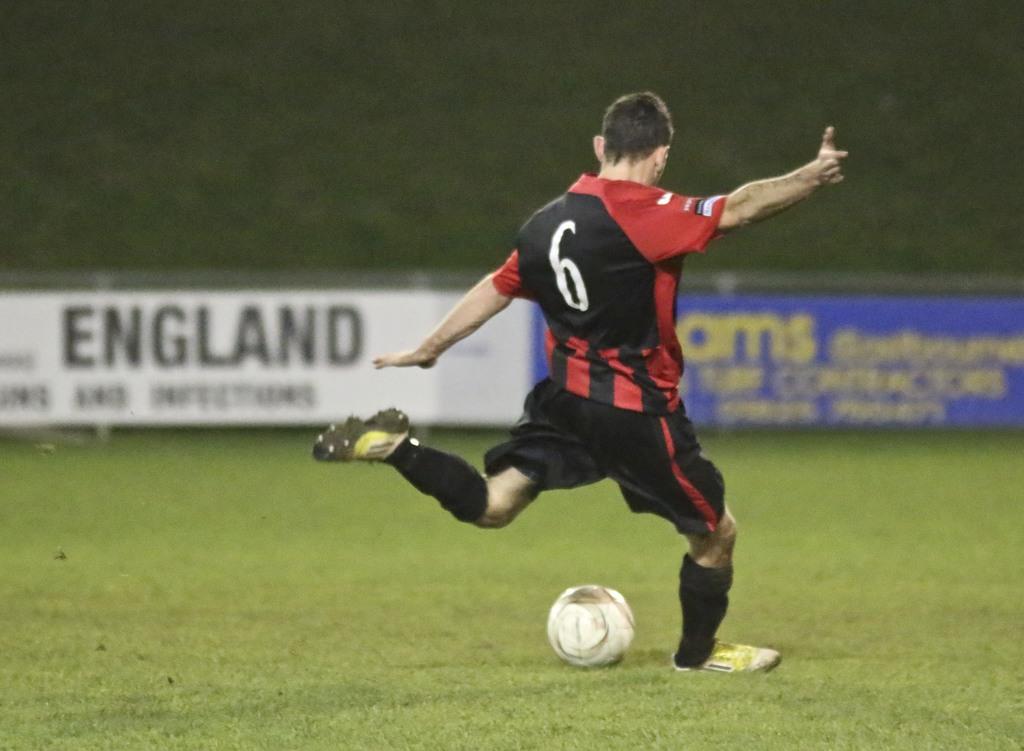What's the number on the back of the player's jersey?
Offer a very short reply. 6. What country is shown on the white banner?
Your answer should be very brief. England. 